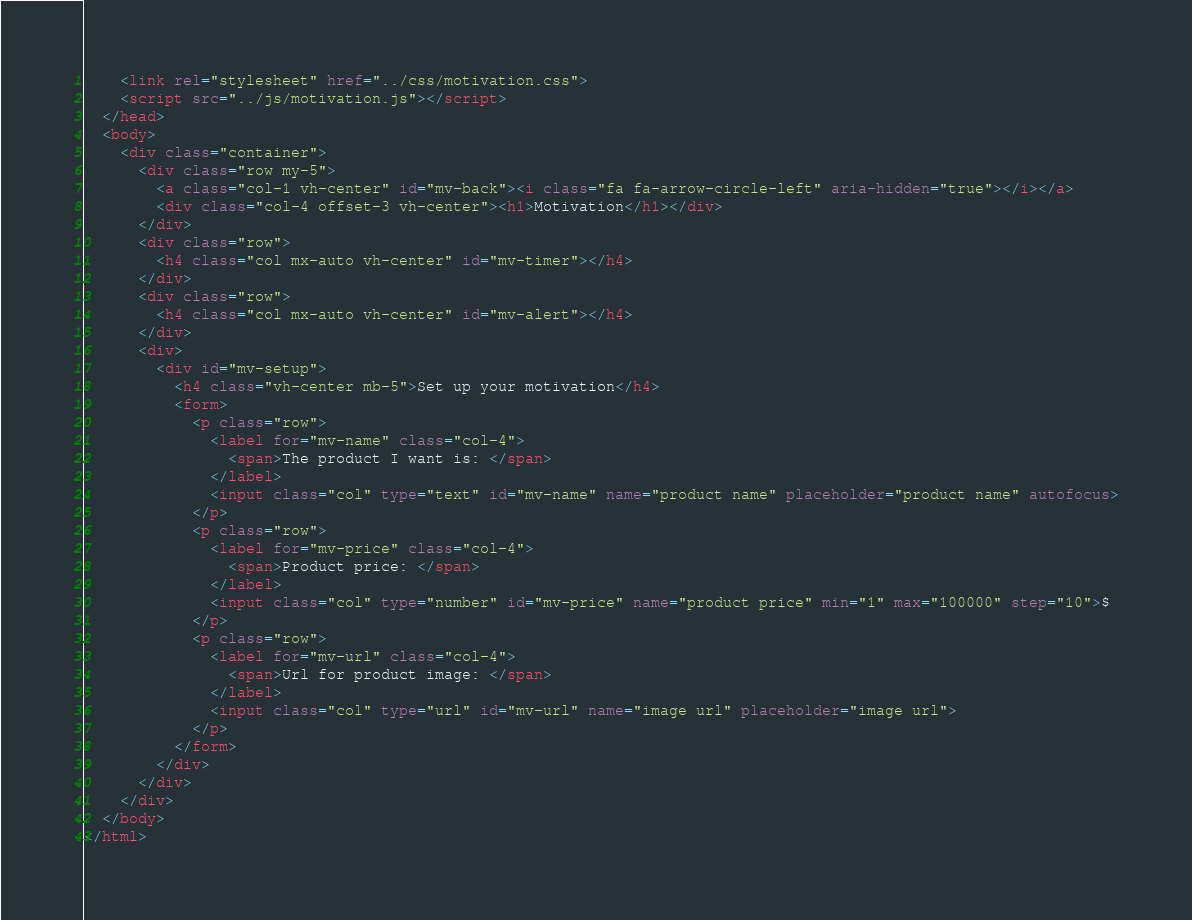Convert code to text. <code><loc_0><loc_0><loc_500><loc_500><_HTML_>    <link rel="stylesheet" href="../css/motivation.css">
    <script src="../js/motivation.js"></script>
  </head>
  <body>
    <div class="container">
      <div class="row my-5">
        <a class="col-1 vh-center" id="mv-back"><i class="fa fa-arrow-circle-left" aria-hidden="true"></i></a>
        <div class="col-4 offset-3 vh-center"><h1>Motivation</h1></div>
      </div>
      <div class="row">
        <h4 class="col mx-auto vh-center" id="mv-timer"></h4>
      </div>
      <div class="row">
        <h4 class="col mx-auto vh-center" id="mv-alert"></h4>
      </div>
      <div>
        <div id="mv-setup">
          <h4 class="vh-center mb-5">Set up your motivation</h4>
          <form>
            <p class="row">
              <label for="mv-name" class="col-4">
                <span>The product I want is: </span>
              </label>
              <input class="col" type="text" id="mv-name" name="product name" placeholder="product name" autofocus>
            </p>
            <p class="row">
              <label for="mv-price" class="col-4">
                <span>Product price: </span>
              </label>
              <input class="col" type="number" id="mv-price" name="product price" min="1" max="100000" step="10">$
            </p>
            <p class="row">
              <label for="mv-url" class="col-4">
                <span>Url for product image: </span>
              </label>
              <input class="col" type="url" id="mv-url" name="image url" placeholder="image url">
            </p>
          </form>
        </div>
      </div>
    </div>
  </body>
</html>
</code> 